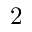Convert formula to latex. <formula><loc_0><loc_0><loc_500><loc_500>2</formula> 